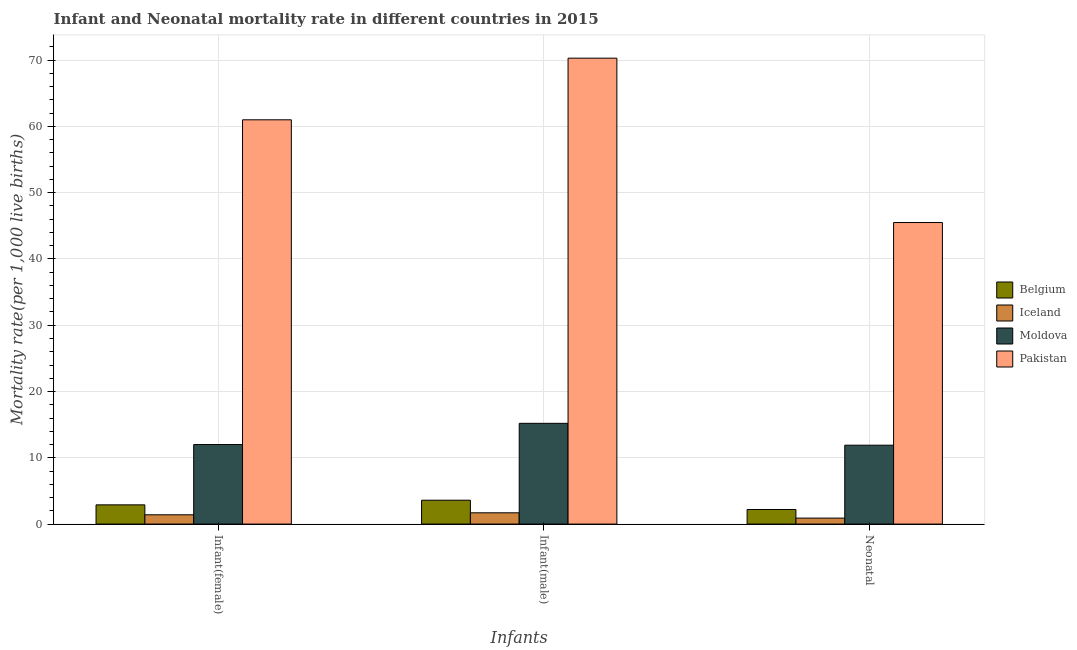How many groups of bars are there?
Your answer should be very brief. 3. Are the number of bars per tick equal to the number of legend labels?
Your response must be concise. Yes. How many bars are there on the 3rd tick from the left?
Make the answer very short. 4. How many bars are there on the 2nd tick from the right?
Your answer should be compact. 4. What is the label of the 2nd group of bars from the left?
Your answer should be very brief. Infant(male). What is the infant mortality rate(male) in Belgium?
Your response must be concise. 3.6. Across all countries, what is the minimum infant mortality rate(female)?
Offer a very short reply. 1.4. In which country was the infant mortality rate(male) minimum?
Offer a terse response. Iceland. What is the total neonatal mortality rate in the graph?
Keep it short and to the point. 60.5. What is the difference between the infant mortality rate(female) in Iceland and that in Moldova?
Keep it short and to the point. -10.6. What is the difference between the infant mortality rate(female) in Pakistan and the infant mortality rate(male) in Moldova?
Ensure brevity in your answer.  45.8. What is the average infant mortality rate(male) per country?
Your response must be concise. 22.7. What is the difference between the neonatal mortality rate and infant mortality rate(female) in Moldova?
Make the answer very short. -0.1. In how many countries, is the infant mortality rate(female) greater than 12 ?
Offer a terse response. 1. What is the ratio of the infant mortality rate(male) in Pakistan to that in Belgium?
Your answer should be very brief. 19.53. Is the infant mortality rate(female) in Belgium less than that in Moldova?
Ensure brevity in your answer.  Yes. Is the difference between the infant mortality rate(male) in Pakistan and Belgium greater than the difference between the infant mortality rate(female) in Pakistan and Belgium?
Give a very brief answer. Yes. What is the difference between the highest and the lowest neonatal mortality rate?
Provide a succinct answer. 44.6. What does the 4th bar from the left in Infant(female) represents?
Make the answer very short. Pakistan. What does the 2nd bar from the right in Infant(female) represents?
Give a very brief answer. Moldova. Is it the case that in every country, the sum of the infant mortality rate(female) and infant mortality rate(male) is greater than the neonatal mortality rate?
Your response must be concise. Yes. Are all the bars in the graph horizontal?
Make the answer very short. No. How many countries are there in the graph?
Provide a succinct answer. 4. Does the graph contain any zero values?
Provide a short and direct response. No. Does the graph contain grids?
Provide a short and direct response. Yes. How many legend labels are there?
Ensure brevity in your answer.  4. How are the legend labels stacked?
Give a very brief answer. Vertical. What is the title of the graph?
Make the answer very short. Infant and Neonatal mortality rate in different countries in 2015. Does "Qatar" appear as one of the legend labels in the graph?
Your answer should be compact. No. What is the label or title of the X-axis?
Provide a succinct answer. Infants. What is the label or title of the Y-axis?
Provide a short and direct response. Mortality rate(per 1,0 live births). What is the Mortality rate(per 1,000 live births) in Pakistan in Infant(female)?
Offer a terse response. 61. What is the Mortality rate(per 1,000 live births) of Belgium in Infant(male)?
Make the answer very short. 3.6. What is the Mortality rate(per 1,000 live births) of Iceland in Infant(male)?
Offer a very short reply. 1.7. What is the Mortality rate(per 1,000 live births) of Moldova in Infant(male)?
Keep it short and to the point. 15.2. What is the Mortality rate(per 1,000 live births) of Pakistan in Infant(male)?
Provide a succinct answer. 70.3. What is the Mortality rate(per 1,000 live births) of Pakistan in Neonatal ?
Offer a very short reply. 45.5. Across all Infants, what is the maximum Mortality rate(per 1,000 live births) of Belgium?
Ensure brevity in your answer.  3.6. Across all Infants, what is the maximum Mortality rate(per 1,000 live births) in Iceland?
Your answer should be compact. 1.7. Across all Infants, what is the maximum Mortality rate(per 1,000 live births) of Moldova?
Offer a very short reply. 15.2. Across all Infants, what is the maximum Mortality rate(per 1,000 live births) of Pakistan?
Offer a terse response. 70.3. Across all Infants, what is the minimum Mortality rate(per 1,000 live births) of Iceland?
Ensure brevity in your answer.  0.9. Across all Infants, what is the minimum Mortality rate(per 1,000 live births) in Pakistan?
Make the answer very short. 45.5. What is the total Mortality rate(per 1,000 live births) of Iceland in the graph?
Provide a succinct answer. 4. What is the total Mortality rate(per 1,000 live births) of Moldova in the graph?
Your answer should be very brief. 39.1. What is the total Mortality rate(per 1,000 live births) in Pakistan in the graph?
Your answer should be very brief. 176.8. What is the difference between the Mortality rate(per 1,000 live births) of Belgium in Infant(female) and that in Infant(male)?
Keep it short and to the point. -0.7. What is the difference between the Mortality rate(per 1,000 live births) in Moldova in Infant(female) and that in Infant(male)?
Give a very brief answer. -3.2. What is the difference between the Mortality rate(per 1,000 live births) of Pakistan in Infant(female) and that in Infant(male)?
Ensure brevity in your answer.  -9.3. What is the difference between the Mortality rate(per 1,000 live births) of Belgium in Infant(female) and that in Neonatal ?
Your response must be concise. 0.7. What is the difference between the Mortality rate(per 1,000 live births) in Iceland in Infant(female) and that in Neonatal ?
Provide a short and direct response. 0.5. What is the difference between the Mortality rate(per 1,000 live births) of Pakistan in Infant(female) and that in Neonatal ?
Your response must be concise. 15.5. What is the difference between the Mortality rate(per 1,000 live births) of Belgium in Infant(male) and that in Neonatal ?
Provide a succinct answer. 1.4. What is the difference between the Mortality rate(per 1,000 live births) of Moldova in Infant(male) and that in Neonatal ?
Give a very brief answer. 3.3. What is the difference between the Mortality rate(per 1,000 live births) in Pakistan in Infant(male) and that in Neonatal ?
Provide a succinct answer. 24.8. What is the difference between the Mortality rate(per 1,000 live births) of Belgium in Infant(female) and the Mortality rate(per 1,000 live births) of Iceland in Infant(male)?
Provide a succinct answer. 1.2. What is the difference between the Mortality rate(per 1,000 live births) of Belgium in Infant(female) and the Mortality rate(per 1,000 live births) of Moldova in Infant(male)?
Keep it short and to the point. -12.3. What is the difference between the Mortality rate(per 1,000 live births) in Belgium in Infant(female) and the Mortality rate(per 1,000 live births) in Pakistan in Infant(male)?
Ensure brevity in your answer.  -67.4. What is the difference between the Mortality rate(per 1,000 live births) in Iceland in Infant(female) and the Mortality rate(per 1,000 live births) in Moldova in Infant(male)?
Make the answer very short. -13.8. What is the difference between the Mortality rate(per 1,000 live births) of Iceland in Infant(female) and the Mortality rate(per 1,000 live births) of Pakistan in Infant(male)?
Offer a very short reply. -68.9. What is the difference between the Mortality rate(per 1,000 live births) of Moldova in Infant(female) and the Mortality rate(per 1,000 live births) of Pakistan in Infant(male)?
Provide a short and direct response. -58.3. What is the difference between the Mortality rate(per 1,000 live births) of Belgium in Infant(female) and the Mortality rate(per 1,000 live births) of Iceland in Neonatal?
Give a very brief answer. 2. What is the difference between the Mortality rate(per 1,000 live births) in Belgium in Infant(female) and the Mortality rate(per 1,000 live births) in Moldova in Neonatal?
Your answer should be compact. -9. What is the difference between the Mortality rate(per 1,000 live births) in Belgium in Infant(female) and the Mortality rate(per 1,000 live births) in Pakistan in Neonatal?
Offer a terse response. -42.6. What is the difference between the Mortality rate(per 1,000 live births) of Iceland in Infant(female) and the Mortality rate(per 1,000 live births) of Moldova in Neonatal?
Offer a terse response. -10.5. What is the difference between the Mortality rate(per 1,000 live births) in Iceland in Infant(female) and the Mortality rate(per 1,000 live births) in Pakistan in Neonatal?
Provide a succinct answer. -44.1. What is the difference between the Mortality rate(per 1,000 live births) in Moldova in Infant(female) and the Mortality rate(per 1,000 live births) in Pakistan in Neonatal?
Offer a terse response. -33.5. What is the difference between the Mortality rate(per 1,000 live births) of Belgium in Infant(male) and the Mortality rate(per 1,000 live births) of Moldova in Neonatal?
Your response must be concise. -8.3. What is the difference between the Mortality rate(per 1,000 live births) of Belgium in Infant(male) and the Mortality rate(per 1,000 live births) of Pakistan in Neonatal?
Make the answer very short. -41.9. What is the difference between the Mortality rate(per 1,000 live births) in Iceland in Infant(male) and the Mortality rate(per 1,000 live births) in Moldova in Neonatal?
Make the answer very short. -10.2. What is the difference between the Mortality rate(per 1,000 live births) in Iceland in Infant(male) and the Mortality rate(per 1,000 live births) in Pakistan in Neonatal?
Provide a short and direct response. -43.8. What is the difference between the Mortality rate(per 1,000 live births) of Moldova in Infant(male) and the Mortality rate(per 1,000 live births) of Pakistan in Neonatal?
Your answer should be compact. -30.3. What is the average Mortality rate(per 1,000 live births) of Moldova per Infants?
Offer a terse response. 13.03. What is the average Mortality rate(per 1,000 live births) in Pakistan per Infants?
Offer a terse response. 58.93. What is the difference between the Mortality rate(per 1,000 live births) of Belgium and Mortality rate(per 1,000 live births) of Iceland in Infant(female)?
Your answer should be compact. 1.5. What is the difference between the Mortality rate(per 1,000 live births) of Belgium and Mortality rate(per 1,000 live births) of Moldova in Infant(female)?
Keep it short and to the point. -9.1. What is the difference between the Mortality rate(per 1,000 live births) in Belgium and Mortality rate(per 1,000 live births) in Pakistan in Infant(female)?
Ensure brevity in your answer.  -58.1. What is the difference between the Mortality rate(per 1,000 live births) of Iceland and Mortality rate(per 1,000 live births) of Moldova in Infant(female)?
Your response must be concise. -10.6. What is the difference between the Mortality rate(per 1,000 live births) of Iceland and Mortality rate(per 1,000 live births) of Pakistan in Infant(female)?
Offer a very short reply. -59.6. What is the difference between the Mortality rate(per 1,000 live births) in Moldova and Mortality rate(per 1,000 live births) in Pakistan in Infant(female)?
Ensure brevity in your answer.  -49. What is the difference between the Mortality rate(per 1,000 live births) in Belgium and Mortality rate(per 1,000 live births) in Pakistan in Infant(male)?
Ensure brevity in your answer.  -66.7. What is the difference between the Mortality rate(per 1,000 live births) in Iceland and Mortality rate(per 1,000 live births) in Pakistan in Infant(male)?
Provide a short and direct response. -68.6. What is the difference between the Mortality rate(per 1,000 live births) of Moldova and Mortality rate(per 1,000 live births) of Pakistan in Infant(male)?
Provide a short and direct response. -55.1. What is the difference between the Mortality rate(per 1,000 live births) of Belgium and Mortality rate(per 1,000 live births) of Moldova in Neonatal ?
Ensure brevity in your answer.  -9.7. What is the difference between the Mortality rate(per 1,000 live births) in Belgium and Mortality rate(per 1,000 live births) in Pakistan in Neonatal ?
Offer a very short reply. -43.3. What is the difference between the Mortality rate(per 1,000 live births) in Iceland and Mortality rate(per 1,000 live births) in Moldova in Neonatal ?
Provide a short and direct response. -11. What is the difference between the Mortality rate(per 1,000 live births) of Iceland and Mortality rate(per 1,000 live births) of Pakistan in Neonatal ?
Provide a short and direct response. -44.6. What is the difference between the Mortality rate(per 1,000 live births) in Moldova and Mortality rate(per 1,000 live births) in Pakistan in Neonatal ?
Provide a succinct answer. -33.6. What is the ratio of the Mortality rate(per 1,000 live births) in Belgium in Infant(female) to that in Infant(male)?
Give a very brief answer. 0.81. What is the ratio of the Mortality rate(per 1,000 live births) of Iceland in Infant(female) to that in Infant(male)?
Keep it short and to the point. 0.82. What is the ratio of the Mortality rate(per 1,000 live births) in Moldova in Infant(female) to that in Infant(male)?
Make the answer very short. 0.79. What is the ratio of the Mortality rate(per 1,000 live births) in Pakistan in Infant(female) to that in Infant(male)?
Provide a succinct answer. 0.87. What is the ratio of the Mortality rate(per 1,000 live births) of Belgium in Infant(female) to that in Neonatal ?
Make the answer very short. 1.32. What is the ratio of the Mortality rate(per 1,000 live births) in Iceland in Infant(female) to that in Neonatal ?
Ensure brevity in your answer.  1.56. What is the ratio of the Mortality rate(per 1,000 live births) of Moldova in Infant(female) to that in Neonatal ?
Provide a short and direct response. 1.01. What is the ratio of the Mortality rate(per 1,000 live births) of Pakistan in Infant(female) to that in Neonatal ?
Keep it short and to the point. 1.34. What is the ratio of the Mortality rate(per 1,000 live births) in Belgium in Infant(male) to that in Neonatal ?
Your answer should be compact. 1.64. What is the ratio of the Mortality rate(per 1,000 live births) of Iceland in Infant(male) to that in Neonatal ?
Give a very brief answer. 1.89. What is the ratio of the Mortality rate(per 1,000 live births) in Moldova in Infant(male) to that in Neonatal ?
Keep it short and to the point. 1.28. What is the ratio of the Mortality rate(per 1,000 live births) in Pakistan in Infant(male) to that in Neonatal ?
Your answer should be compact. 1.55. What is the difference between the highest and the second highest Mortality rate(per 1,000 live births) in Belgium?
Your answer should be very brief. 0.7. What is the difference between the highest and the second highest Mortality rate(per 1,000 live births) in Iceland?
Give a very brief answer. 0.3. What is the difference between the highest and the second highest Mortality rate(per 1,000 live births) of Moldova?
Provide a succinct answer. 3.2. What is the difference between the highest and the second highest Mortality rate(per 1,000 live births) of Pakistan?
Give a very brief answer. 9.3. What is the difference between the highest and the lowest Mortality rate(per 1,000 live births) in Belgium?
Provide a succinct answer. 1.4. What is the difference between the highest and the lowest Mortality rate(per 1,000 live births) in Iceland?
Give a very brief answer. 0.8. What is the difference between the highest and the lowest Mortality rate(per 1,000 live births) of Pakistan?
Your answer should be compact. 24.8. 